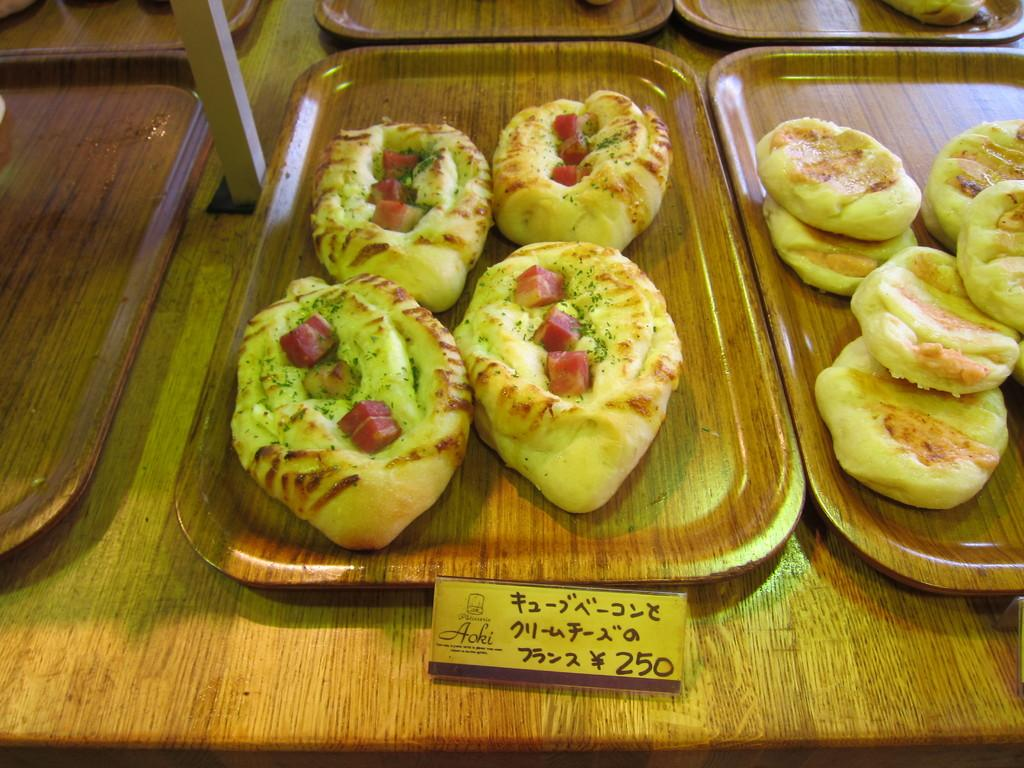What objects are on the table in the image? There are planets and food on the table in the image. What can be seen at the bottom of the image? There is a price strip at the bottom of the image. How many mittens can be seen in the image? There are no mittens present in the image. Is there any quicksand visible in the image? There is no quicksand present in the image. 